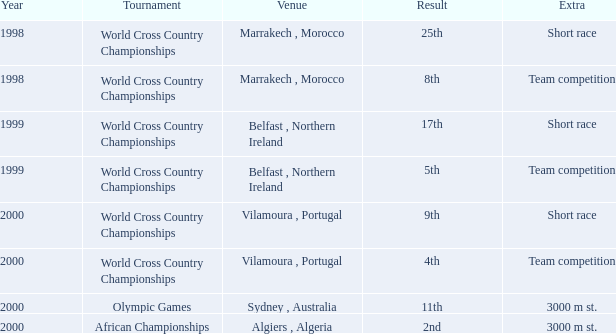Tell me the extra for tournament of olympic games 3000 m st. 